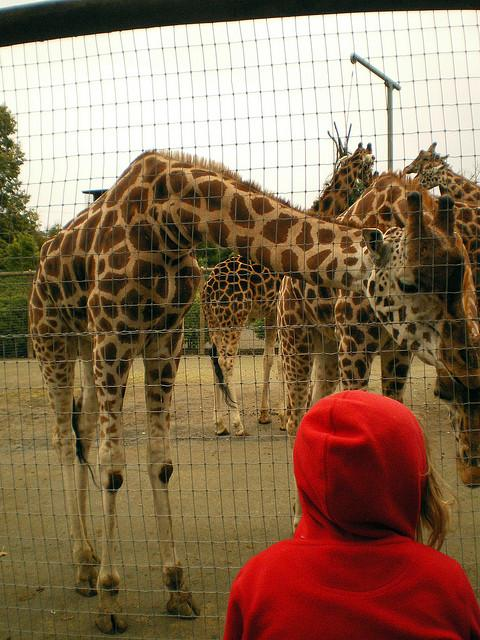How many of the giraffes are attentive to the child?

Choices:
A) three
B) two
C) four
D) one two 